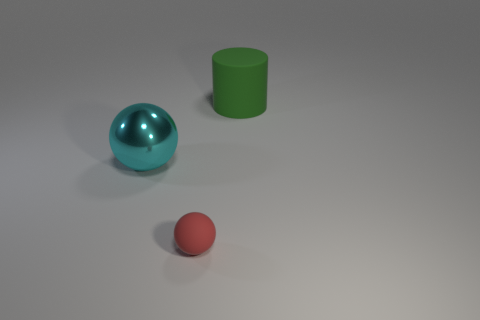Are there any other things that are made of the same material as the cyan object?
Make the answer very short. No. Are there more big spheres that are left of the cyan metal object than big green matte objects that are to the left of the tiny red rubber ball?
Keep it short and to the point. No. Do the cylinder and the red rubber object have the same size?
Give a very brief answer. No. There is a rubber object to the right of the matte object that is in front of the large cyan metallic object; what is its color?
Make the answer very short. Green. The small matte thing has what color?
Your answer should be very brief. Red. Is there another cylinder of the same color as the large cylinder?
Make the answer very short. No. There is a rubber object to the left of the green thing; is it the same color as the metal ball?
Your answer should be compact. No. What number of objects are either rubber things that are to the left of the green rubber thing or green things?
Keep it short and to the point. 2. There is a rubber ball; are there any red spheres left of it?
Give a very brief answer. No. Are the thing that is to the right of the red matte object and the large cyan ball made of the same material?
Your answer should be compact. No. 